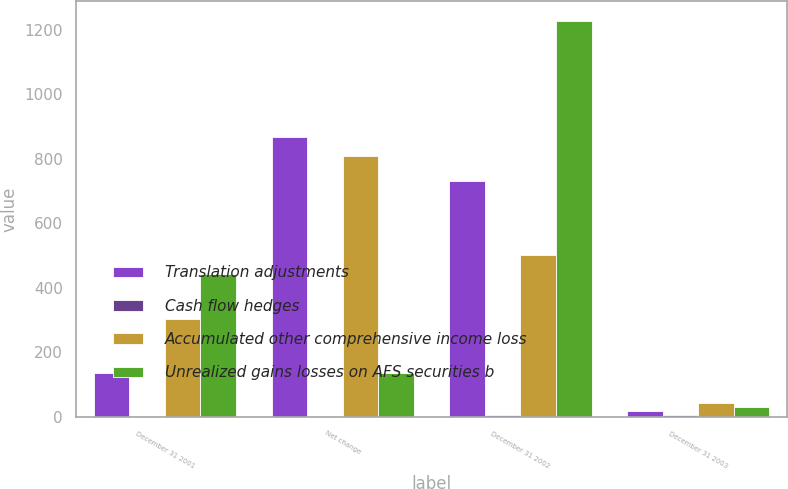Convert chart. <chart><loc_0><loc_0><loc_500><loc_500><stacked_bar_chart><ecel><fcel>December 31 2001<fcel>Net change<fcel>December 31 2002<fcel>December 31 2003<nl><fcel>Translation adjustments<fcel>135<fcel>866<fcel>731<fcel>19<nl><fcel>Cash flow hedges<fcel>2<fcel>4<fcel>6<fcel>6<nl><fcel>Accumulated other comprehensive income loss<fcel>305<fcel>807<fcel>502<fcel>43<nl><fcel>Unrealized gains losses on AFS securities b<fcel>442<fcel>135<fcel>1227<fcel>30<nl></chart> 